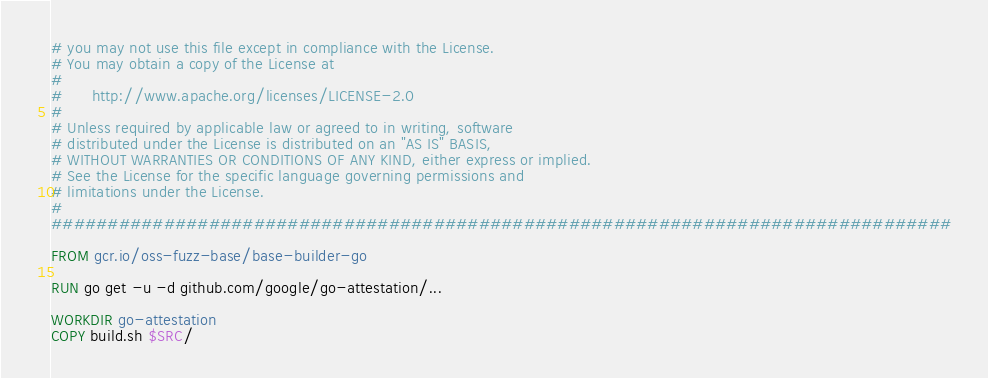<code> <loc_0><loc_0><loc_500><loc_500><_Dockerfile_># you may not use this file except in compliance with the License.
# You may obtain a copy of the License at
#
#      http://www.apache.org/licenses/LICENSE-2.0
#
# Unless required by applicable law or agreed to in writing, software
# distributed under the License is distributed on an "AS IS" BASIS,
# WITHOUT WARRANTIES OR CONDITIONS OF ANY KIND, either express or implied.
# See the License for the specific language governing permissions and
# limitations under the License.
#
################################################################################

FROM gcr.io/oss-fuzz-base/base-builder-go

RUN go get -u -d github.com/google/go-attestation/...

WORKDIR go-attestation
COPY build.sh $SRC/
</code> 